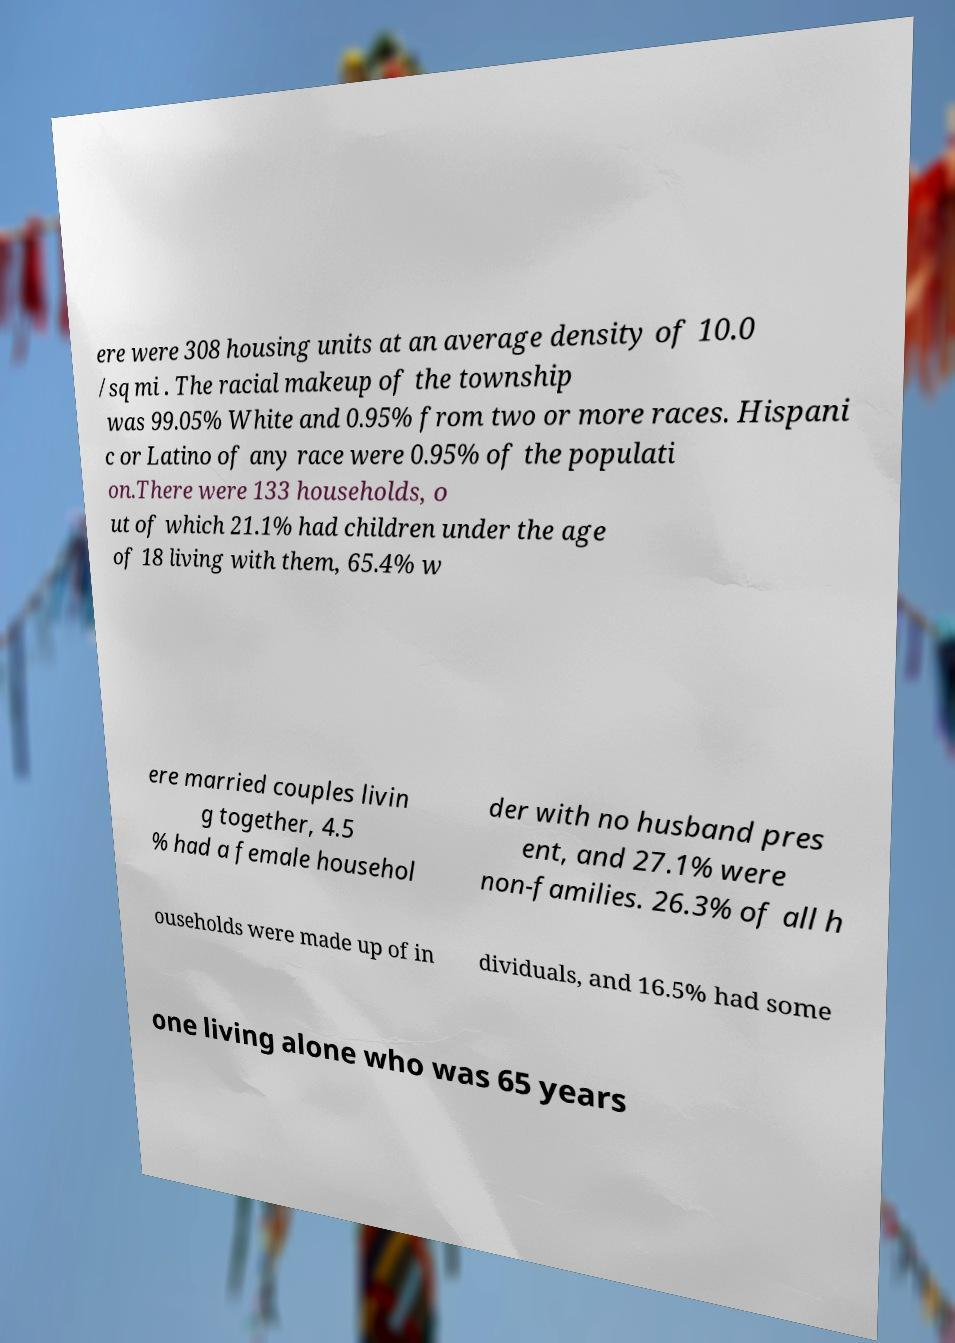Please identify and transcribe the text found in this image. ere were 308 housing units at an average density of 10.0 /sq mi . The racial makeup of the township was 99.05% White and 0.95% from two or more races. Hispani c or Latino of any race were 0.95% of the populati on.There were 133 households, o ut of which 21.1% had children under the age of 18 living with them, 65.4% w ere married couples livin g together, 4.5 % had a female househol der with no husband pres ent, and 27.1% were non-families. 26.3% of all h ouseholds were made up of in dividuals, and 16.5% had some one living alone who was 65 years 